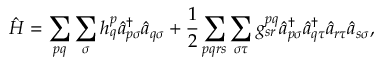Convert formula to latex. <formula><loc_0><loc_0><loc_500><loc_500>\hat { H } = \sum _ { p q } \sum _ { \sigma } h _ { q } ^ { p } \hat { a } _ { p \sigma } ^ { \dagger } \hat { a } _ { q \sigma } + \frac { 1 } { 2 } \sum _ { p q r s } \sum _ { \sigma \tau } g _ { s r } ^ { p q } \hat { a } _ { p \sigma } ^ { \dagger } \hat { a } _ { q \tau } ^ { \dagger } \hat { a } _ { r \tau } \hat { a } _ { s \sigma } ,</formula> 